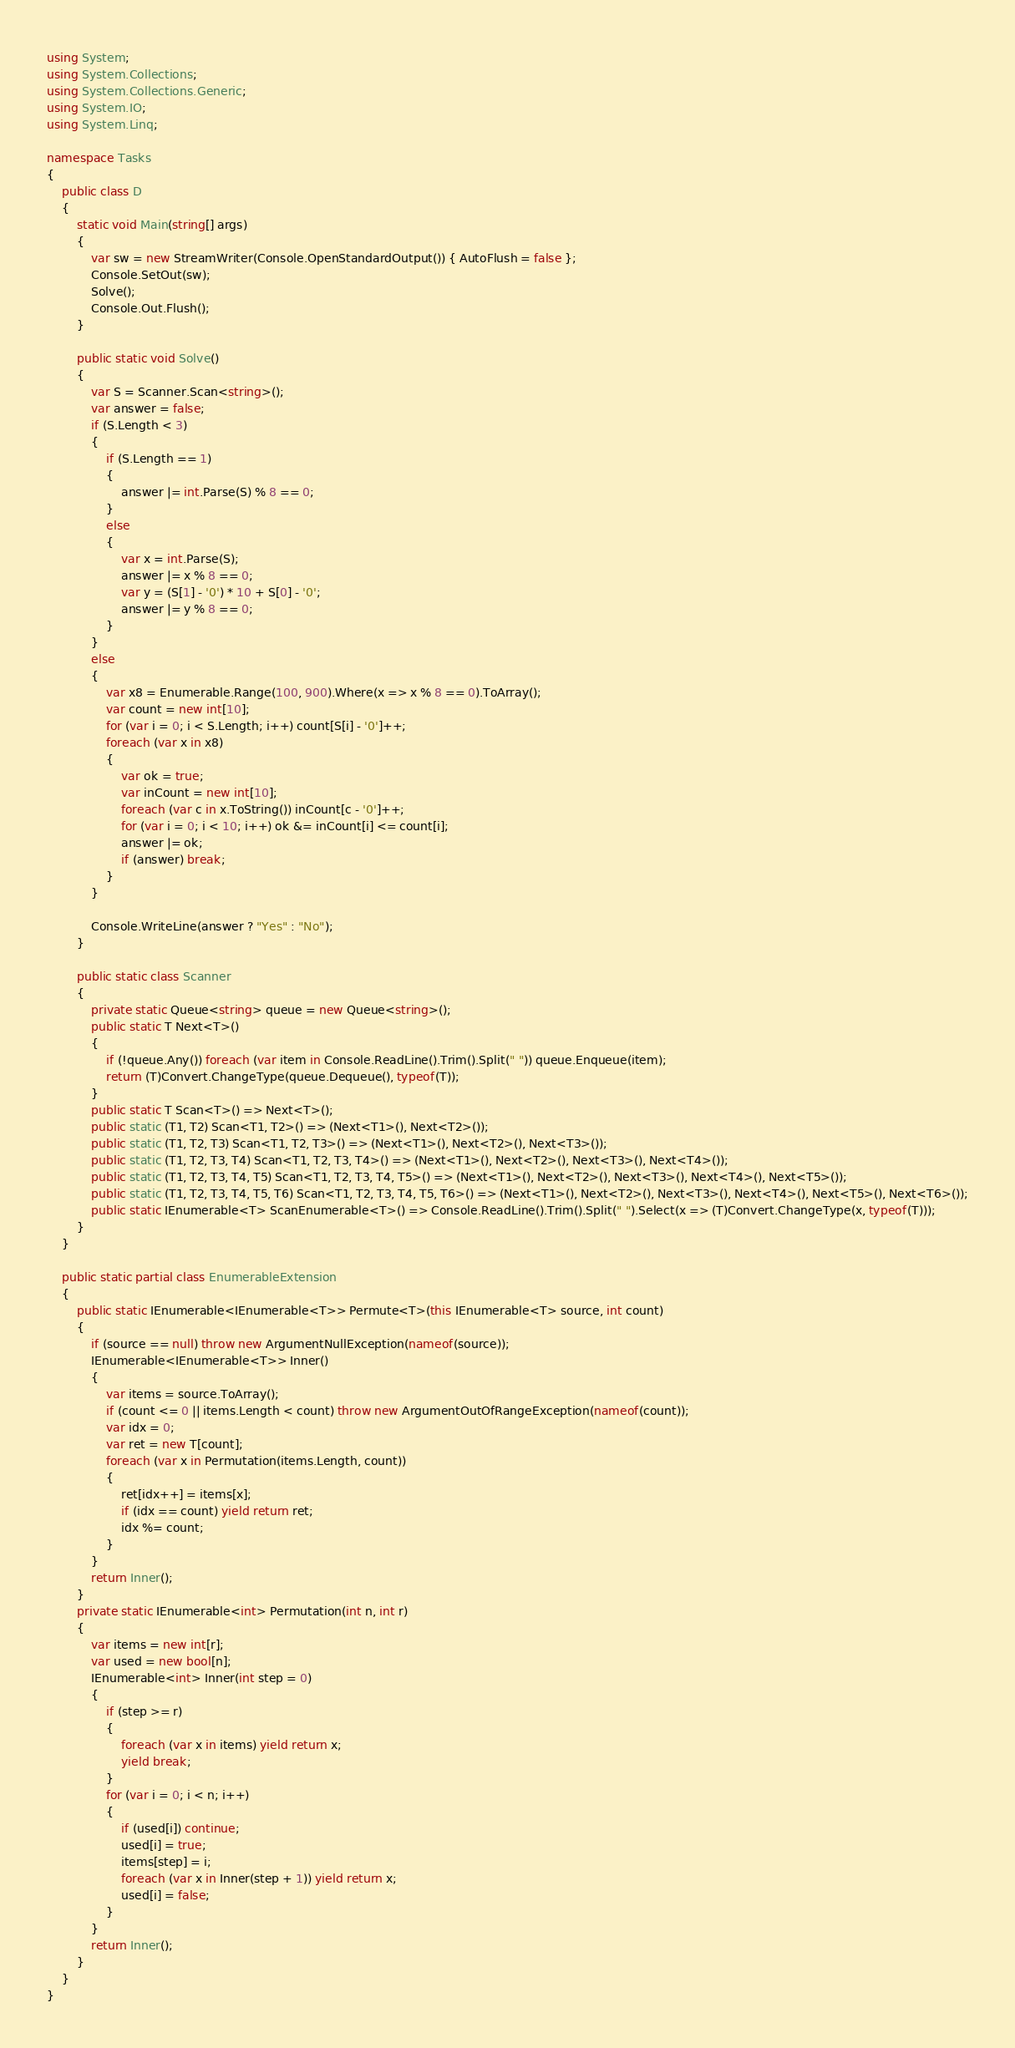<code> <loc_0><loc_0><loc_500><loc_500><_C#_>using System;
using System.Collections;
using System.Collections.Generic;
using System.IO;
using System.Linq;

namespace Tasks
{
    public class D
    {
        static void Main(string[] args)
        {
            var sw = new StreamWriter(Console.OpenStandardOutput()) { AutoFlush = false };
            Console.SetOut(sw);
            Solve();
            Console.Out.Flush();
        }

        public static void Solve()
        {
            var S = Scanner.Scan<string>();
            var answer = false;
            if (S.Length < 3)
            {
                if (S.Length == 1)
                {
                    answer |= int.Parse(S) % 8 == 0;
                }
                else
                {
                    var x = int.Parse(S);
                    answer |= x % 8 == 0;
                    var y = (S[1] - '0') * 10 + S[0] - '0';
                    answer |= y % 8 == 0;
                }
            }
            else
            {
                var x8 = Enumerable.Range(100, 900).Where(x => x % 8 == 0).ToArray();
                var count = new int[10];
                for (var i = 0; i < S.Length; i++) count[S[i] - '0']++;
                foreach (var x in x8)
                {
                    var ok = true;
                    var inCount = new int[10];
                    foreach (var c in x.ToString()) inCount[c - '0']++;
                    for (var i = 0; i < 10; i++) ok &= inCount[i] <= count[i];
                    answer |= ok;
                    if (answer) break;
                }
            }

            Console.WriteLine(answer ? "Yes" : "No");
        }

        public static class Scanner
        {
            private static Queue<string> queue = new Queue<string>();
            public static T Next<T>()
            {
                if (!queue.Any()) foreach (var item in Console.ReadLine().Trim().Split(" ")) queue.Enqueue(item);
                return (T)Convert.ChangeType(queue.Dequeue(), typeof(T));
            }
            public static T Scan<T>() => Next<T>();
            public static (T1, T2) Scan<T1, T2>() => (Next<T1>(), Next<T2>());
            public static (T1, T2, T3) Scan<T1, T2, T3>() => (Next<T1>(), Next<T2>(), Next<T3>());
            public static (T1, T2, T3, T4) Scan<T1, T2, T3, T4>() => (Next<T1>(), Next<T2>(), Next<T3>(), Next<T4>());
            public static (T1, T2, T3, T4, T5) Scan<T1, T2, T3, T4, T5>() => (Next<T1>(), Next<T2>(), Next<T3>(), Next<T4>(), Next<T5>());
            public static (T1, T2, T3, T4, T5, T6) Scan<T1, T2, T3, T4, T5, T6>() => (Next<T1>(), Next<T2>(), Next<T3>(), Next<T4>(), Next<T5>(), Next<T6>());
            public static IEnumerable<T> ScanEnumerable<T>() => Console.ReadLine().Trim().Split(" ").Select(x => (T)Convert.ChangeType(x, typeof(T)));
        }
    }

    public static partial class EnumerableExtension
    {
        public static IEnumerable<IEnumerable<T>> Permute<T>(this IEnumerable<T> source, int count)
        {
            if (source == null) throw new ArgumentNullException(nameof(source));
            IEnumerable<IEnumerable<T>> Inner()
            {
                var items = source.ToArray();
                if (count <= 0 || items.Length < count) throw new ArgumentOutOfRangeException(nameof(count));
                var idx = 0;
                var ret = new T[count];
                foreach (var x in Permutation(items.Length, count))
                {
                    ret[idx++] = items[x];
                    if (idx == count) yield return ret;
                    idx %= count;
                }
            }
            return Inner();
        }
        private static IEnumerable<int> Permutation(int n, int r)
        {
            var items = new int[r];
            var used = new bool[n];
            IEnumerable<int> Inner(int step = 0)
            {
                if (step >= r)
                {
                    foreach (var x in items) yield return x;
                    yield break;
                }
                for (var i = 0; i < n; i++)
                {
                    if (used[i]) continue;
                    used[i] = true;
                    items[step] = i;
                    foreach (var x in Inner(step + 1)) yield return x;
                    used[i] = false;
                }
            }
            return Inner();
        }
    }
}
</code> 